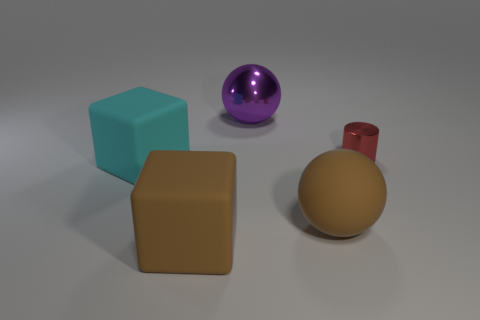What material is the object that is the same color as the rubber ball?
Make the answer very short. Rubber. Are there fewer small shiny cylinders than brown metallic cubes?
Ensure brevity in your answer.  No. Is there any other thing that has the same size as the cyan cube?
Provide a short and direct response. Yes. Is the color of the cylinder the same as the big rubber sphere?
Keep it short and to the point. No. Is the number of cyan matte blocks greater than the number of big yellow metal cylinders?
Ensure brevity in your answer.  Yes. How many other things are there of the same color as the tiny object?
Ensure brevity in your answer.  0. There is a big sphere behind the big cyan rubber cube; how many big brown blocks are left of it?
Offer a terse response. 1. There is a small red shiny thing; are there any purple shiny objects right of it?
Your answer should be very brief. No. There is a large thing in front of the ball that is in front of the purple ball; what shape is it?
Your answer should be very brief. Cube. Is the number of brown rubber balls behind the red metallic cylinder less than the number of tiny metal cylinders that are in front of the purple thing?
Offer a very short reply. Yes. 